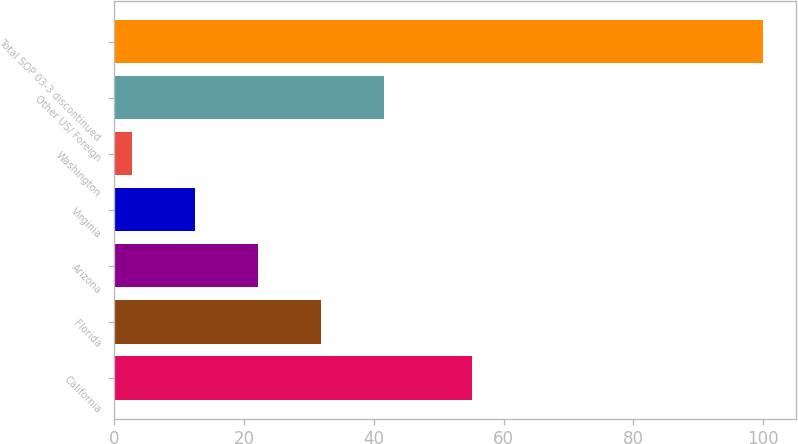Convert chart to OTSL. <chart><loc_0><loc_0><loc_500><loc_500><bar_chart><fcel>California<fcel>Florida<fcel>Arizona<fcel>Virginia<fcel>Washington<fcel>Other US/ Foreign<fcel>Total SOP 03-3 discontinued<nl><fcel>55.2<fcel>31.89<fcel>22.16<fcel>12.43<fcel>2.7<fcel>41.62<fcel>100<nl></chart> 